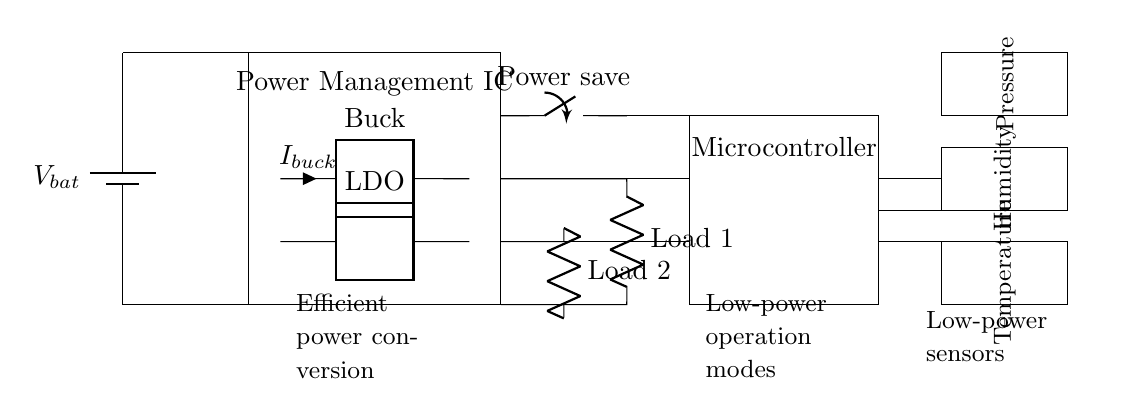What is the main purpose of the Power Management IC? The Power Management IC is responsible for regulating the output voltage from the battery and providing efficient power conversion to the loads.
Answer: Power regulation What type of converter is present in the circuit? The circuit includes a buck converter which is used to step down the voltage to a lower level suitable for the loads.
Answer: Buck converter What is the role of the LDO in this circuit? The Low Dropout Regulator (LDO) is used to provide a stable lower voltage to the load with minimal voltage drop, ensuring efficient operation.
Answer: Voltage regulation How many sensors are connected to the microcontroller? There are three sensors connected: temperature, humidity, and pressure sensors, each providing specific data to the microcontroller.
Answer: Three What is the function of the power save switch? The power save switch is used to toggle the circuit between active and low-power modes, helping to extend battery life during periods of inactivity.
Answer: Power saving What are the two types of loads depicted in this circuit? The circuit shows two types of loads, which are typically resistive elements, operating under the management of the power management IC.
Answer: Load 1 and Load 2 Which component is critical for extending battery life? The Power Management IC is critical for extending battery life, as it efficiently manages power distribution and reduces energy consumption.
Answer: Power Management IC 